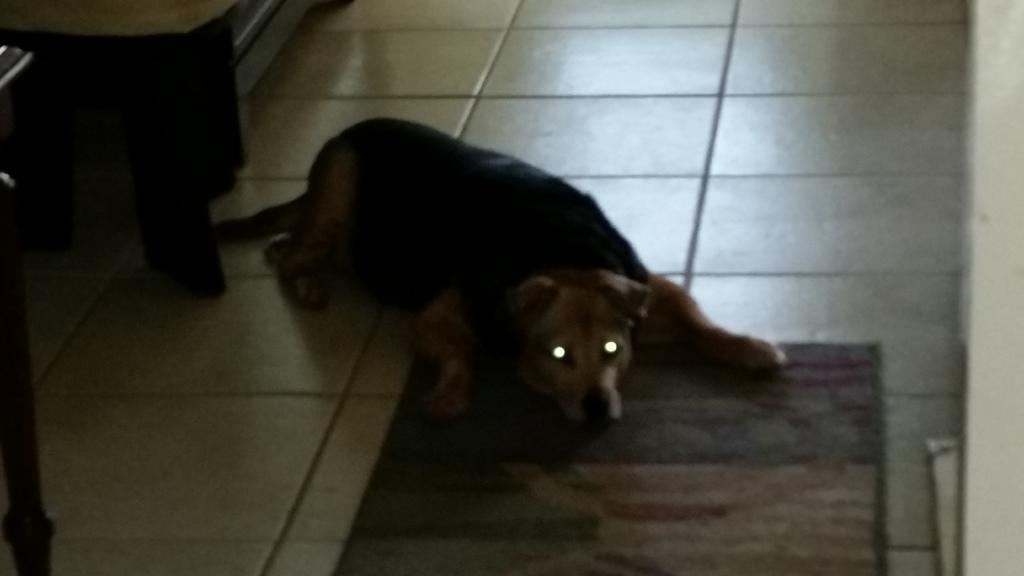What is the main subject in the foreground of the image? There is a dog lying down on the floor in the foreground of the image. What type of surface is the dog lying on? There is a carpet on the floor. Can you describe any other objects in the image? There is a table-like object in the top left corner of the image. What type of authority does the dog have in the image? The image does not depict any authority; it simply shows a dog lying down on a carpet. 